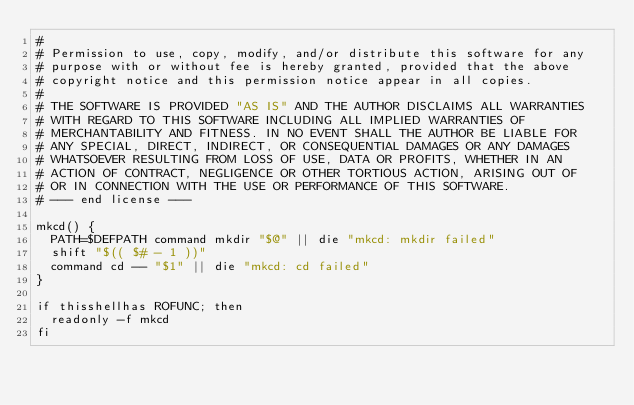<code> <loc_0><loc_0><loc_500><loc_500><_ObjectiveC_>#
# Permission to use, copy, modify, and/or distribute this software for any
# purpose with or without fee is hereby granted, provided that the above
# copyright notice and this permission notice appear in all copies.
#
# THE SOFTWARE IS PROVIDED "AS IS" AND THE AUTHOR DISCLAIMS ALL WARRANTIES
# WITH REGARD TO THIS SOFTWARE INCLUDING ALL IMPLIED WARRANTIES OF
# MERCHANTABILITY AND FITNESS. IN NO EVENT SHALL THE AUTHOR BE LIABLE FOR
# ANY SPECIAL, DIRECT, INDIRECT, OR CONSEQUENTIAL DAMAGES OR ANY DAMAGES
# WHATSOEVER RESULTING FROM LOSS OF USE, DATA OR PROFITS, WHETHER IN AN
# ACTION OF CONTRACT, NEGLIGENCE OR OTHER TORTIOUS ACTION, ARISING OUT OF
# OR IN CONNECTION WITH THE USE OR PERFORMANCE OF THIS SOFTWARE.
# --- end license ---

mkcd() {
	PATH=$DEFPATH command mkdir "$@" || die "mkcd: mkdir failed"
	shift "$(( $# - 1 ))"
	command cd -- "$1" || die "mkcd: cd failed"
}

if thisshellhas ROFUNC; then
	readonly -f mkcd
fi
</code> 